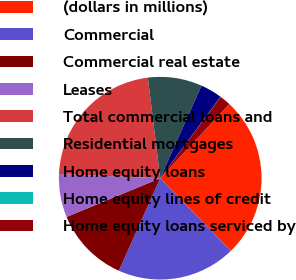Convert chart to OTSL. <chart><loc_0><loc_0><loc_500><loc_500><pie_chart><fcel>(dollars in millions)<fcel>Commercial<fcel>Commercial real estate<fcel>Leases<fcel>Total commercial loans and<fcel>Residential mortgages<fcel>Home equity loans<fcel>Home equity lines of credit<fcel>Home equity loans serviced by<nl><fcel>25.82%<fcel>18.94%<fcel>12.07%<fcel>6.91%<fcel>22.38%<fcel>8.63%<fcel>3.47%<fcel>0.03%<fcel>1.75%<nl></chart> 